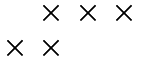Convert formula to latex. <formula><loc_0><loc_0><loc_500><loc_500>\begin{matrix} & \times & \times & \times \\ \times & \times & & \end{matrix}</formula> 